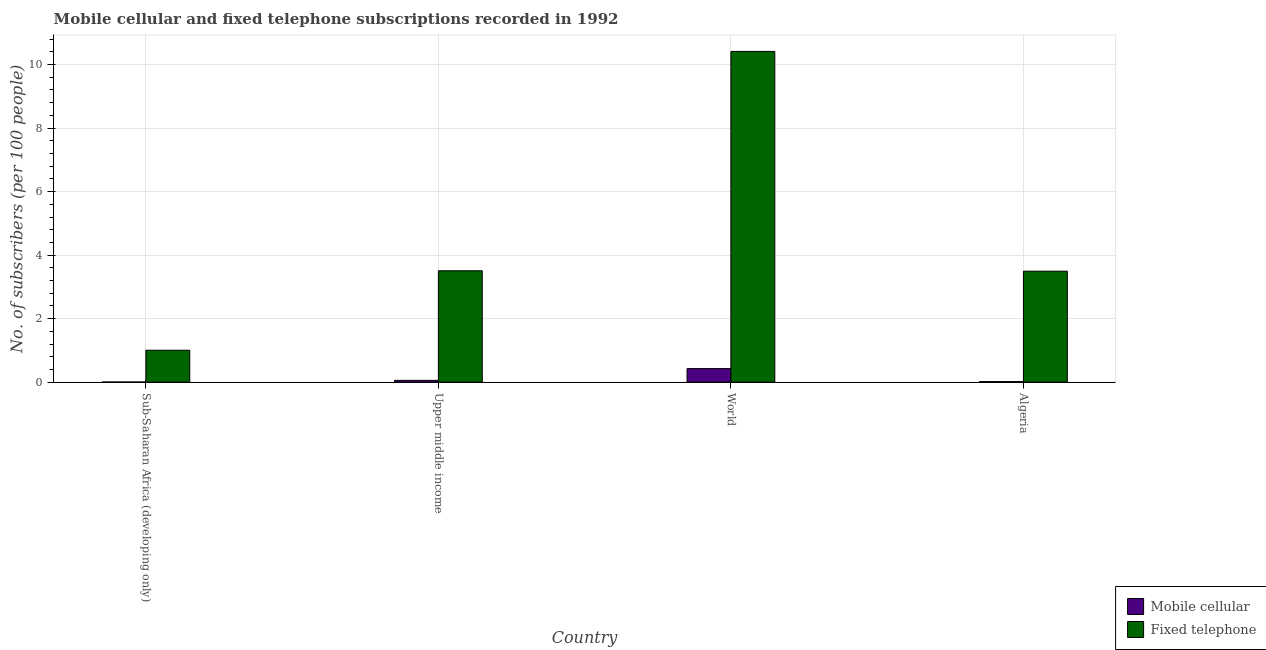How many groups of bars are there?
Give a very brief answer. 4. Are the number of bars per tick equal to the number of legend labels?
Your answer should be compact. Yes. Are the number of bars on each tick of the X-axis equal?
Your answer should be compact. Yes. What is the label of the 4th group of bars from the left?
Give a very brief answer. Algeria. What is the number of mobile cellular subscribers in World?
Offer a terse response. 0.43. Across all countries, what is the maximum number of mobile cellular subscribers?
Ensure brevity in your answer.  0.43. Across all countries, what is the minimum number of fixed telephone subscribers?
Your answer should be compact. 1. In which country was the number of fixed telephone subscribers minimum?
Provide a short and direct response. Sub-Saharan Africa (developing only). What is the total number of fixed telephone subscribers in the graph?
Ensure brevity in your answer.  18.42. What is the difference between the number of fixed telephone subscribers in Sub-Saharan Africa (developing only) and that in Upper middle income?
Your answer should be compact. -2.5. What is the difference between the number of fixed telephone subscribers in Upper middle income and the number of mobile cellular subscribers in World?
Keep it short and to the point. 3.08. What is the average number of fixed telephone subscribers per country?
Make the answer very short. 4.61. What is the difference between the number of mobile cellular subscribers and number of fixed telephone subscribers in Sub-Saharan Africa (developing only)?
Offer a terse response. -1. In how many countries, is the number of mobile cellular subscribers greater than 1.6 ?
Make the answer very short. 0. What is the ratio of the number of fixed telephone subscribers in Algeria to that in World?
Your answer should be very brief. 0.34. Is the number of mobile cellular subscribers in Sub-Saharan Africa (developing only) less than that in Upper middle income?
Keep it short and to the point. Yes. What is the difference between the highest and the second highest number of mobile cellular subscribers?
Offer a very short reply. 0.37. What is the difference between the highest and the lowest number of fixed telephone subscribers?
Give a very brief answer. 9.41. Is the sum of the number of mobile cellular subscribers in Algeria and Upper middle income greater than the maximum number of fixed telephone subscribers across all countries?
Make the answer very short. No. What does the 1st bar from the left in Upper middle income represents?
Make the answer very short. Mobile cellular. What does the 2nd bar from the right in Upper middle income represents?
Keep it short and to the point. Mobile cellular. What is the difference between two consecutive major ticks on the Y-axis?
Your answer should be compact. 2. Are the values on the major ticks of Y-axis written in scientific E-notation?
Offer a very short reply. No. Where does the legend appear in the graph?
Make the answer very short. Bottom right. How many legend labels are there?
Ensure brevity in your answer.  2. What is the title of the graph?
Make the answer very short. Mobile cellular and fixed telephone subscriptions recorded in 1992. What is the label or title of the Y-axis?
Your answer should be very brief. No. of subscribers (per 100 people). What is the No. of subscribers (per 100 people) in Mobile cellular in Sub-Saharan Africa (developing only)?
Ensure brevity in your answer.  0. What is the No. of subscribers (per 100 people) of Fixed telephone in Sub-Saharan Africa (developing only)?
Provide a short and direct response. 1. What is the No. of subscribers (per 100 people) in Mobile cellular in Upper middle income?
Make the answer very short. 0.06. What is the No. of subscribers (per 100 people) of Fixed telephone in Upper middle income?
Offer a terse response. 3.51. What is the No. of subscribers (per 100 people) of Mobile cellular in World?
Provide a short and direct response. 0.43. What is the No. of subscribers (per 100 people) in Fixed telephone in World?
Your response must be concise. 10.42. What is the No. of subscribers (per 100 people) of Mobile cellular in Algeria?
Provide a succinct answer. 0.02. What is the No. of subscribers (per 100 people) in Fixed telephone in Algeria?
Provide a short and direct response. 3.49. Across all countries, what is the maximum No. of subscribers (per 100 people) in Mobile cellular?
Give a very brief answer. 0.43. Across all countries, what is the maximum No. of subscribers (per 100 people) in Fixed telephone?
Offer a terse response. 10.42. Across all countries, what is the minimum No. of subscribers (per 100 people) in Mobile cellular?
Your answer should be compact. 0. Across all countries, what is the minimum No. of subscribers (per 100 people) in Fixed telephone?
Provide a succinct answer. 1. What is the total No. of subscribers (per 100 people) in Mobile cellular in the graph?
Your answer should be very brief. 0.5. What is the total No. of subscribers (per 100 people) in Fixed telephone in the graph?
Make the answer very short. 18.42. What is the difference between the No. of subscribers (per 100 people) in Mobile cellular in Sub-Saharan Africa (developing only) and that in Upper middle income?
Provide a succinct answer. -0.05. What is the difference between the No. of subscribers (per 100 people) in Fixed telephone in Sub-Saharan Africa (developing only) and that in Upper middle income?
Your answer should be very brief. -2.5. What is the difference between the No. of subscribers (per 100 people) in Mobile cellular in Sub-Saharan Africa (developing only) and that in World?
Your response must be concise. -0.42. What is the difference between the No. of subscribers (per 100 people) of Fixed telephone in Sub-Saharan Africa (developing only) and that in World?
Offer a very short reply. -9.41. What is the difference between the No. of subscribers (per 100 people) in Mobile cellular in Sub-Saharan Africa (developing only) and that in Algeria?
Keep it short and to the point. -0.01. What is the difference between the No. of subscribers (per 100 people) of Fixed telephone in Sub-Saharan Africa (developing only) and that in Algeria?
Offer a terse response. -2.49. What is the difference between the No. of subscribers (per 100 people) of Mobile cellular in Upper middle income and that in World?
Keep it short and to the point. -0.37. What is the difference between the No. of subscribers (per 100 people) in Fixed telephone in Upper middle income and that in World?
Offer a terse response. -6.91. What is the difference between the No. of subscribers (per 100 people) in Mobile cellular in Upper middle income and that in Algeria?
Keep it short and to the point. 0.04. What is the difference between the No. of subscribers (per 100 people) of Fixed telephone in Upper middle income and that in Algeria?
Make the answer very short. 0.01. What is the difference between the No. of subscribers (per 100 people) in Mobile cellular in World and that in Algeria?
Your response must be concise. 0.41. What is the difference between the No. of subscribers (per 100 people) in Fixed telephone in World and that in Algeria?
Provide a short and direct response. 6.92. What is the difference between the No. of subscribers (per 100 people) in Mobile cellular in Sub-Saharan Africa (developing only) and the No. of subscribers (per 100 people) in Fixed telephone in Upper middle income?
Provide a succinct answer. -3.5. What is the difference between the No. of subscribers (per 100 people) of Mobile cellular in Sub-Saharan Africa (developing only) and the No. of subscribers (per 100 people) of Fixed telephone in World?
Keep it short and to the point. -10.41. What is the difference between the No. of subscribers (per 100 people) in Mobile cellular in Sub-Saharan Africa (developing only) and the No. of subscribers (per 100 people) in Fixed telephone in Algeria?
Give a very brief answer. -3.49. What is the difference between the No. of subscribers (per 100 people) of Mobile cellular in Upper middle income and the No. of subscribers (per 100 people) of Fixed telephone in World?
Provide a short and direct response. -10.36. What is the difference between the No. of subscribers (per 100 people) in Mobile cellular in Upper middle income and the No. of subscribers (per 100 people) in Fixed telephone in Algeria?
Keep it short and to the point. -3.44. What is the difference between the No. of subscribers (per 100 people) of Mobile cellular in World and the No. of subscribers (per 100 people) of Fixed telephone in Algeria?
Provide a succinct answer. -3.07. What is the average No. of subscribers (per 100 people) in Mobile cellular per country?
Make the answer very short. 0.13. What is the average No. of subscribers (per 100 people) of Fixed telephone per country?
Your answer should be compact. 4.61. What is the difference between the No. of subscribers (per 100 people) in Mobile cellular and No. of subscribers (per 100 people) in Fixed telephone in Sub-Saharan Africa (developing only)?
Make the answer very short. -1. What is the difference between the No. of subscribers (per 100 people) of Mobile cellular and No. of subscribers (per 100 people) of Fixed telephone in Upper middle income?
Your response must be concise. -3.45. What is the difference between the No. of subscribers (per 100 people) of Mobile cellular and No. of subscribers (per 100 people) of Fixed telephone in World?
Your answer should be very brief. -9.99. What is the difference between the No. of subscribers (per 100 people) in Mobile cellular and No. of subscribers (per 100 people) in Fixed telephone in Algeria?
Give a very brief answer. -3.48. What is the ratio of the No. of subscribers (per 100 people) in Mobile cellular in Sub-Saharan Africa (developing only) to that in Upper middle income?
Keep it short and to the point. 0.06. What is the ratio of the No. of subscribers (per 100 people) of Fixed telephone in Sub-Saharan Africa (developing only) to that in Upper middle income?
Offer a very short reply. 0.29. What is the ratio of the No. of subscribers (per 100 people) in Mobile cellular in Sub-Saharan Africa (developing only) to that in World?
Offer a terse response. 0.01. What is the ratio of the No. of subscribers (per 100 people) in Fixed telephone in Sub-Saharan Africa (developing only) to that in World?
Your answer should be very brief. 0.1. What is the ratio of the No. of subscribers (per 100 people) in Mobile cellular in Sub-Saharan Africa (developing only) to that in Algeria?
Your answer should be compact. 0.2. What is the ratio of the No. of subscribers (per 100 people) of Fixed telephone in Sub-Saharan Africa (developing only) to that in Algeria?
Offer a terse response. 0.29. What is the ratio of the No. of subscribers (per 100 people) in Mobile cellular in Upper middle income to that in World?
Make the answer very short. 0.13. What is the ratio of the No. of subscribers (per 100 people) of Fixed telephone in Upper middle income to that in World?
Offer a very short reply. 0.34. What is the ratio of the No. of subscribers (per 100 people) of Mobile cellular in Upper middle income to that in Algeria?
Your answer should be compact. 3.27. What is the ratio of the No. of subscribers (per 100 people) of Mobile cellular in World to that in Algeria?
Your answer should be compact. 24.59. What is the ratio of the No. of subscribers (per 100 people) of Fixed telephone in World to that in Algeria?
Offer a very short reply. 2.98. What is the difference between the highest and the second highest No. of subscribers (per 100 people) of Mobile cellular?
Ensure brevity in your answer.  0.37. What is the difference between the highest and the second highest No. of subscribers (per 100 people) of Fixed telephone?
Offer a very short reply. 6.91. What is the difference between the highest and the lowest No. of subscribers (per 100 people) in Mobile cellular?
Offer a terse response. 0.42. What is the difference between the highest and the lowest No. of subscribers (per 100 people) in Fixed telephone?
Your answer should be compact. 9.41. 